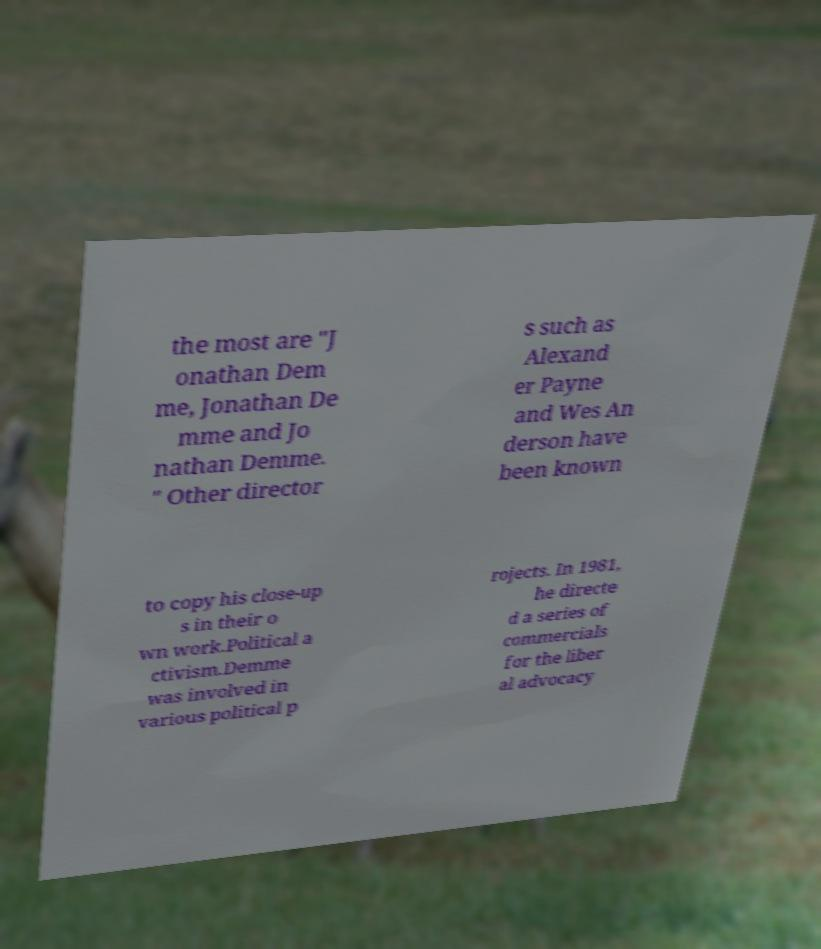For documentation purposes, I need the text within this image transcribed. Could you provide that? the most are "J onathan Dem me, Jonathan De mme and Jo nathan Demme. " Other director s such as Alexand er Payne and Wes An derson have been known to copy his close-up s in their o wn work.Political a ctivism.Demme was involved in various political p rojects. In 1981, he directe d a series of commercials for the liber al advocacy 